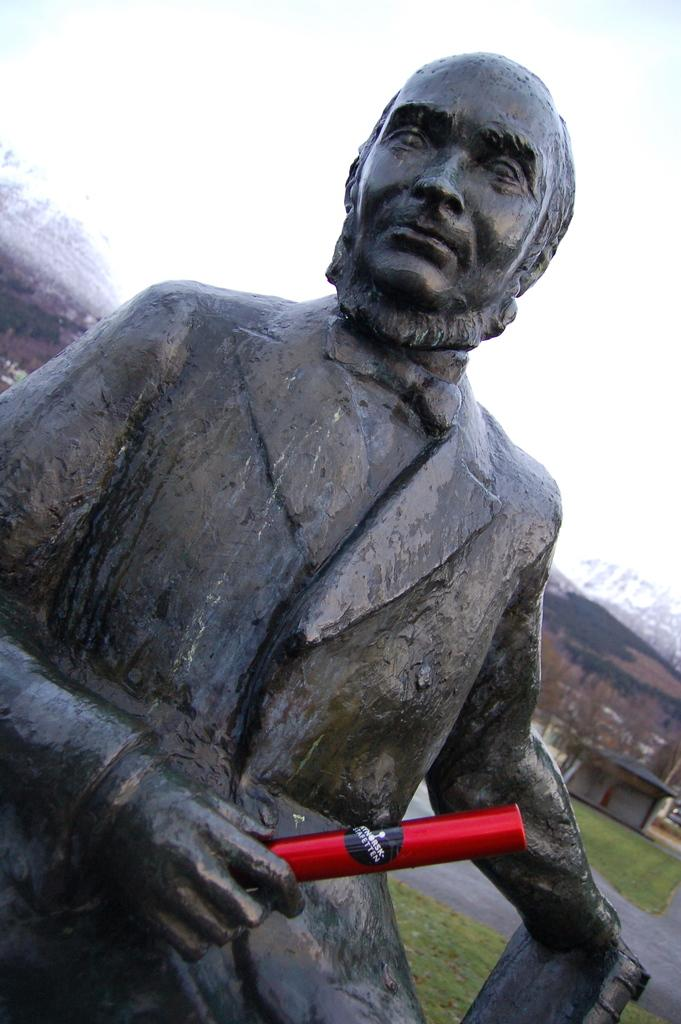What is the main subject of the image? There is a statue in the image. What is the statue holding? The statue is holding an item. What can be seen in the distance in the image? There are hills in the background of the image. Are there any structures visible in the background? Yes, there is a shed in the background of the image. What is visible above the statue and the background? The sky is visible in the background of the image. What type of drug is the statue holding in the image? There is no drug present in the image; the statue is holding an item, but it is not specified as a drug. 